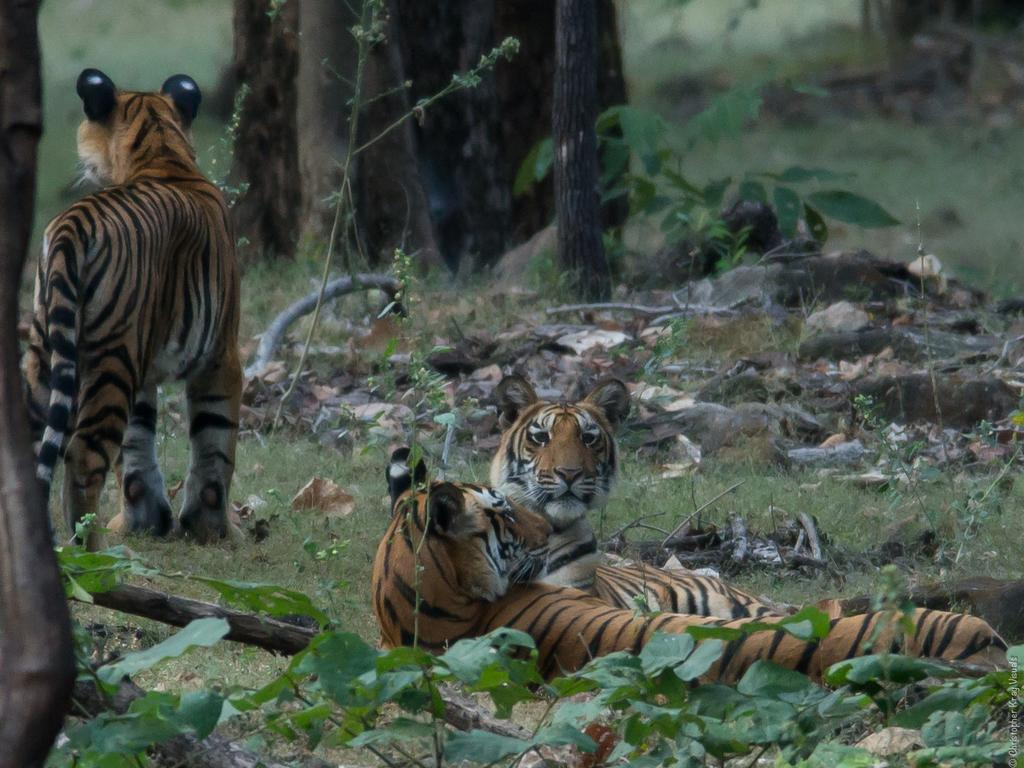What animals are present in the image? There are tigers in the image. Where are the tigers located? The tigers are on the grass. What can be seen in the background of the image? There are trees and plants in the background of the image. What type of badge is the woman wearing in the image? There is no woman present in the image, and therefore no badge to be seen. 